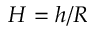Convert formula to latex. <formula><loc_0><loc_0><loc_500><loc_500>H = h / R</formula> 